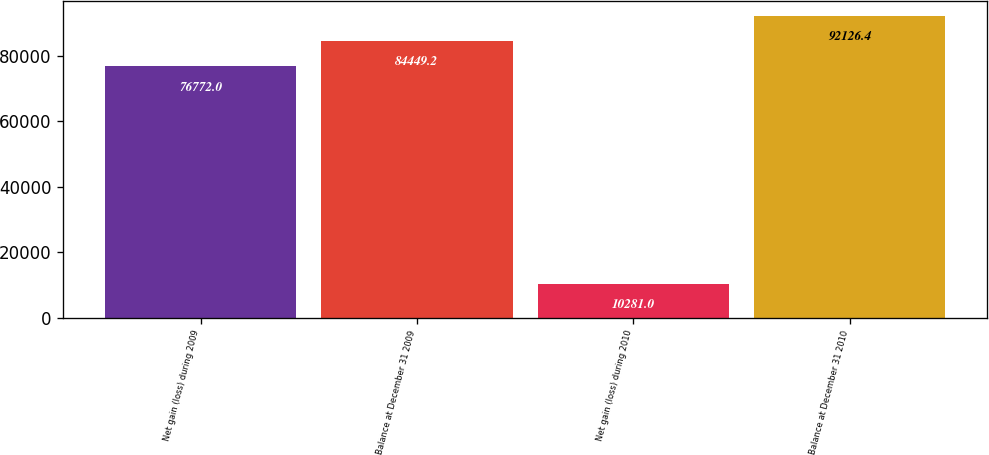Convert chart. <chart><loc_0><loc_0><loc_500><loc_500><bar_chart><fcel>Net gain (loss) during 2009<fcel>Balance at December 31 2009<fcel>Net gain (loss) during 2010<fcel>Balance at December 31 2010<nl><fcel>76772<fcel>84449.2<fcel>10281<fcel>92126.4<nl></chart> 